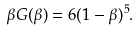<formula> <loc_0><loc_0><loc_500><loc_500>\beta G ( \beta ) = 6 ( 1 - \beta ) ^ { 5 } .</formula> 